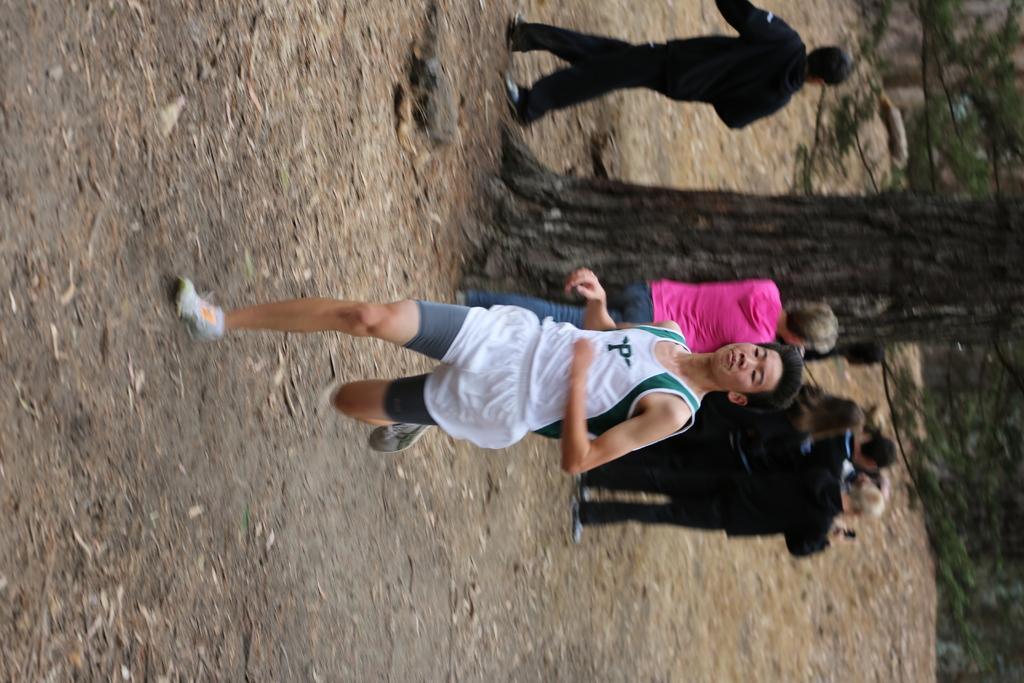Please provide a concise description of this image. This is a rotated image. In this image there are a few people standing and walking, one of them is running. In the background there are trees. 